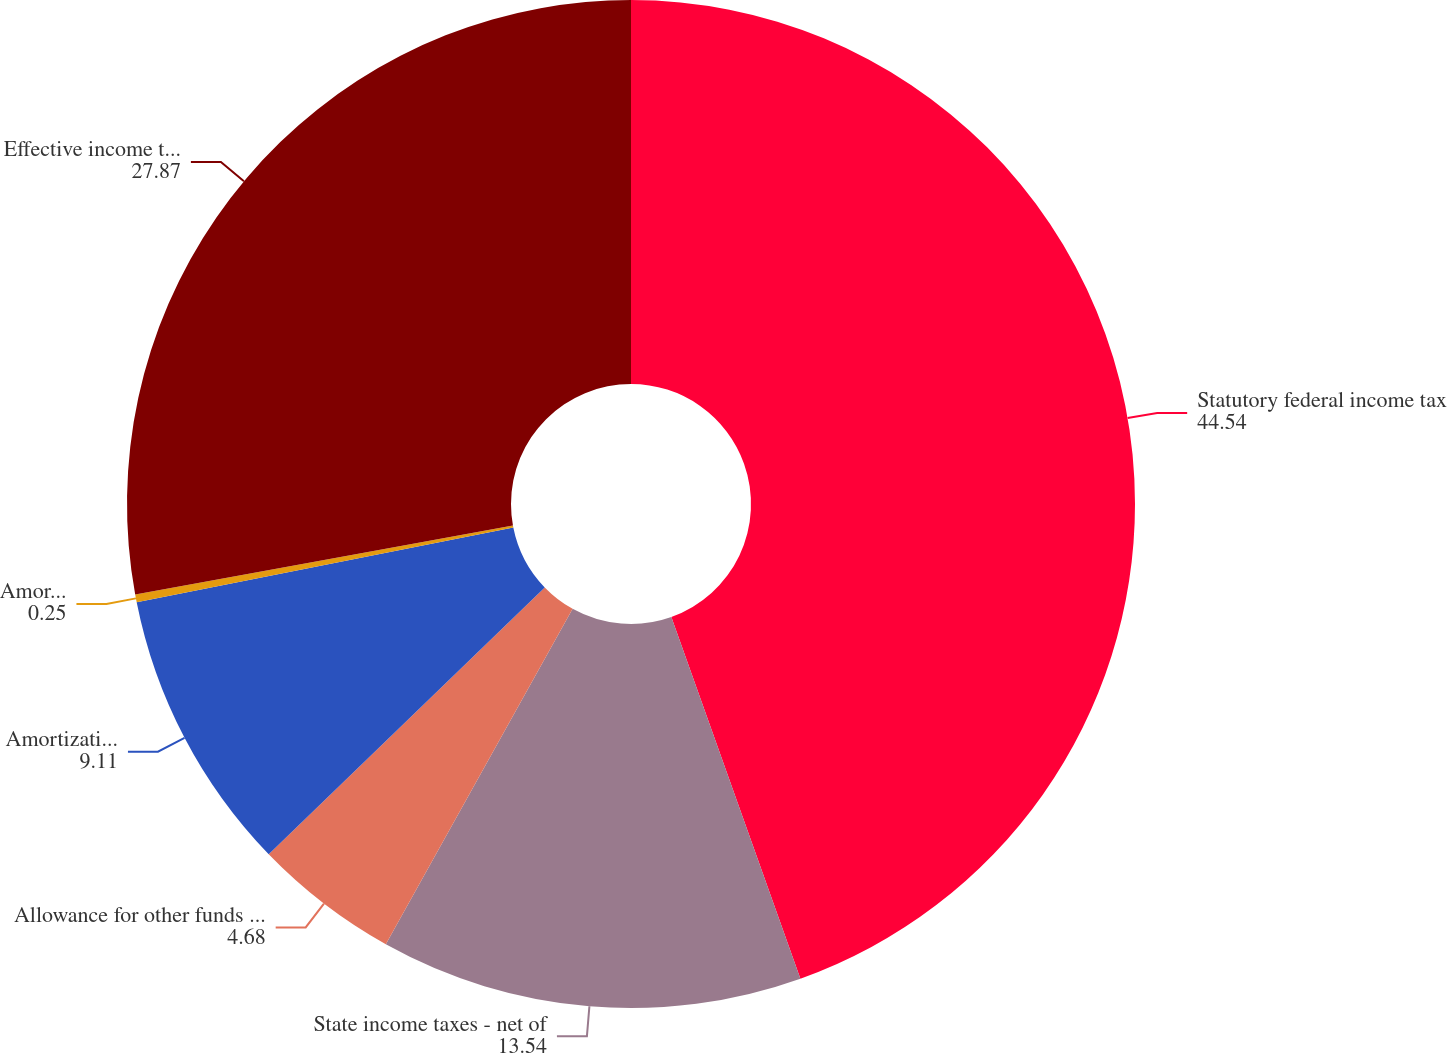Convert chart. <chart><loc_0><loc_0><loc_500><loc_500><pie_chart><fcel>Statutory federal income tax<fcel>State income taxes - net of<fcel>Allowance for other funds used<fcel>Amortization of ITCs - FPL<fcel>Amortization of deferred<fcel>Effective income tax rate<nl><fcel>44.54%<fcel>13.54%<fcel>4.68%<fcel>9.11%<fcel>0.25%<fcel>27.87%<nl></chart> 